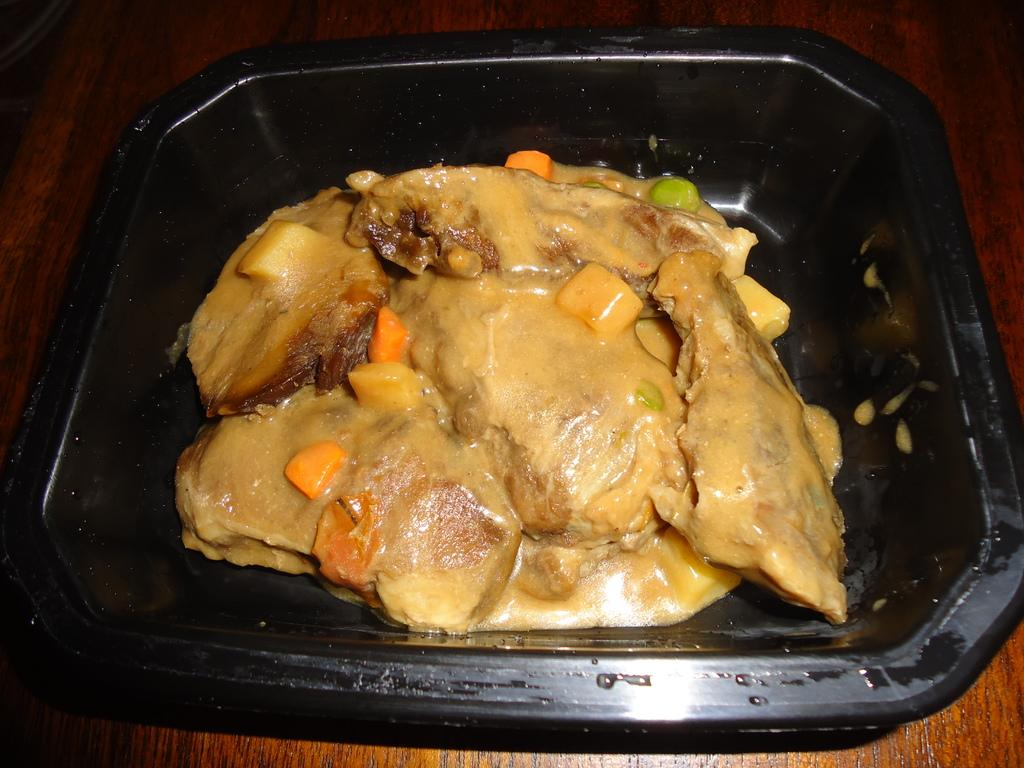What piece of furniture is present in the image? There is a table in the image. What is placed on the table? There is a bowl on the table. What is inside the bowl? There is a food item in the bowl. How many jellyfish can be seen swimming in the bowl? There are no jellyfish present in the image; the bowl contains a food item. 